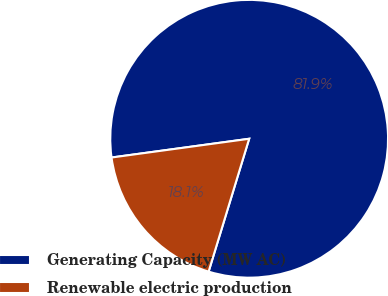<chart> <loc_0><loc_0><loc_500><loc_500><pie_chart><fcel>Generating Capacity (MW AC)<fcel>Renewable electric production<nl><fcel>81.87%<fcel>18.13%<nl></chart> 